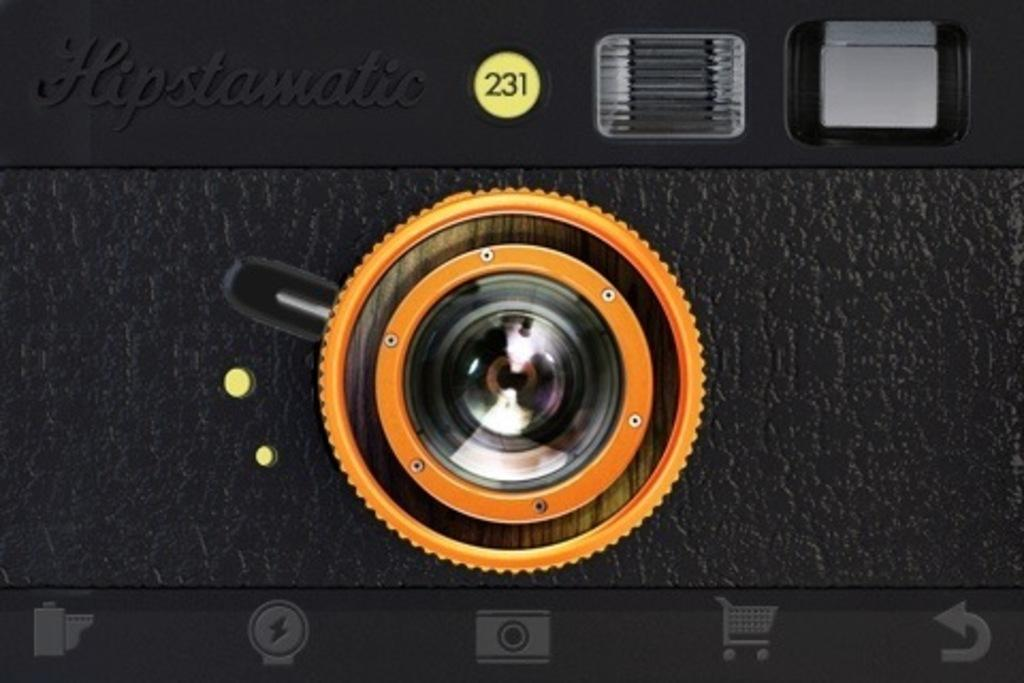What object is the main subject of the image? There is a camera in the image. What is the color of the camera? The camera is black in color. Are there any words or letters on the camera? Yes, there is text written on the camera. Are there any numbers on the camera? Yes, there are numbers written on the camera. Where is the harbor located in the image? There is no harbor present in the image; it features a camera. What type of baseball equipment can be seen in the image? There is no baseball equipment present in the image; it features a camera. 